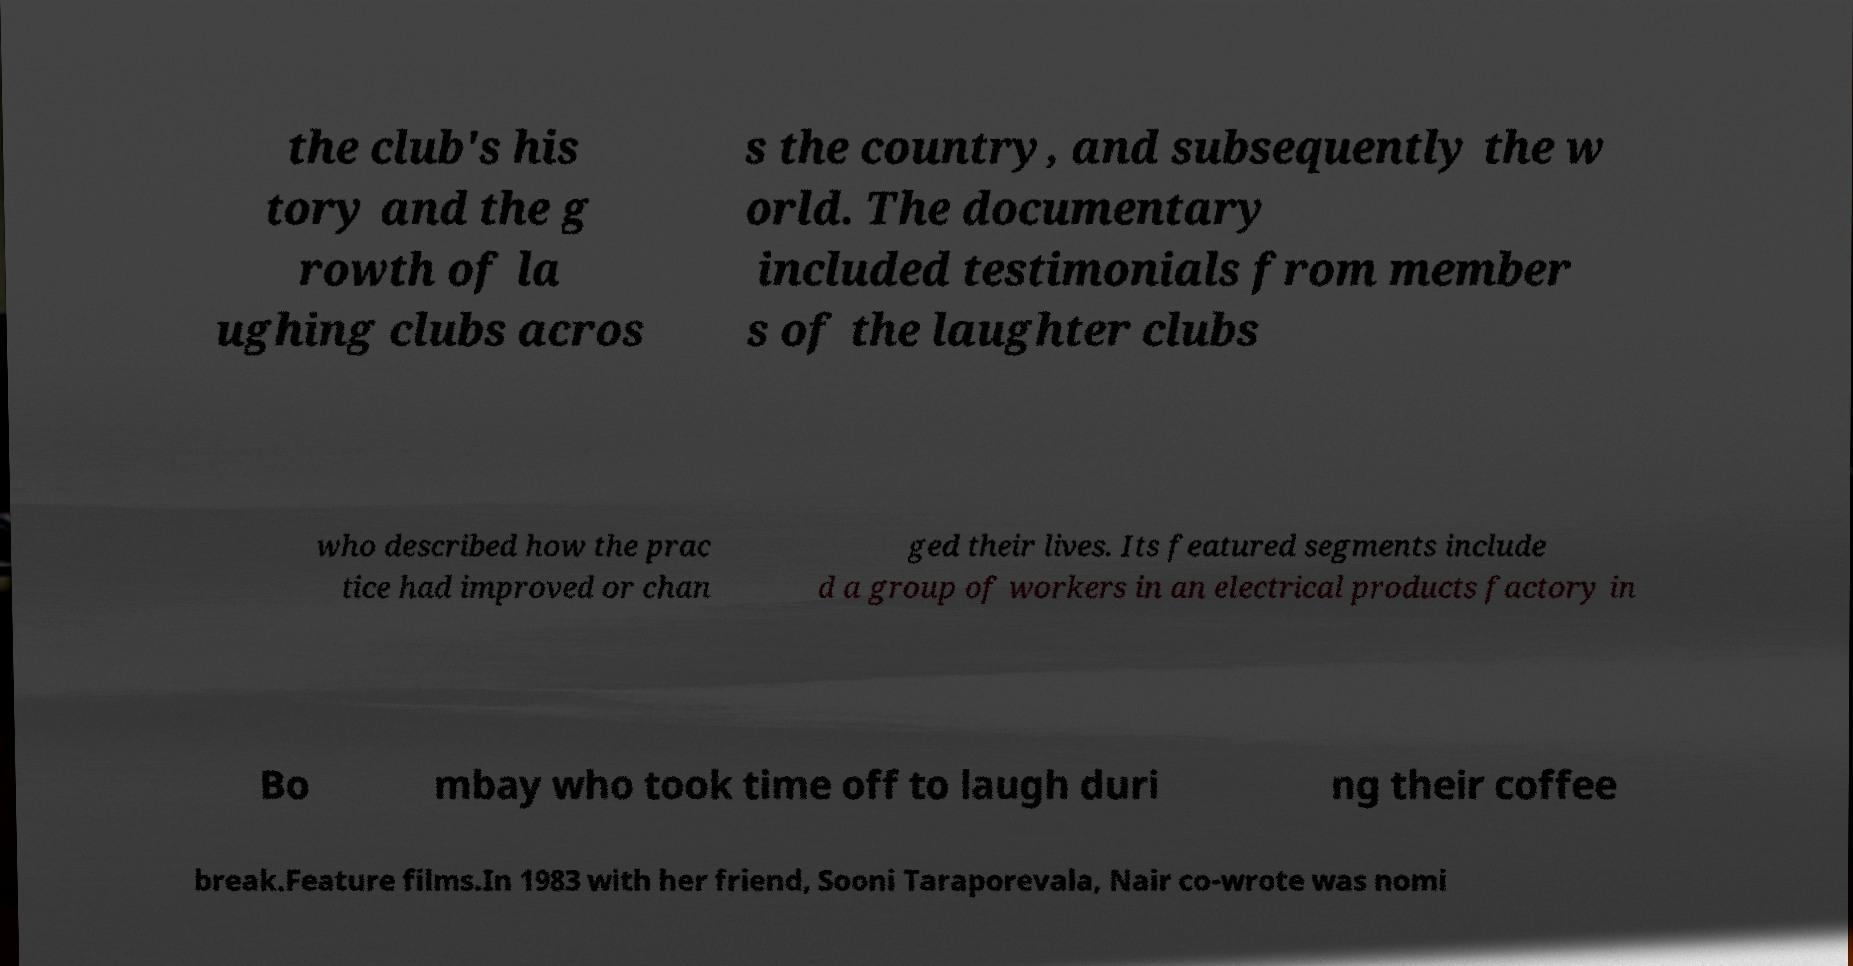There's text embedded in this image that I need extracted. Can you transcribe it verbatim? the club's his tory and the g rowth of la ughing clubs acros s the country, and subsequently the w orld. The documentary included testimonials from member s of the laughter clubs who described how the prac tice had improved or chan ged their lives. Its featured segments include d a group of workers in an electrical products factory in Bo mbay who took time off to laugh duri ng their coffee break.Feature films.In 1983 with her friend, Sooni Taraporevala, Nair co-wrote was nomi 